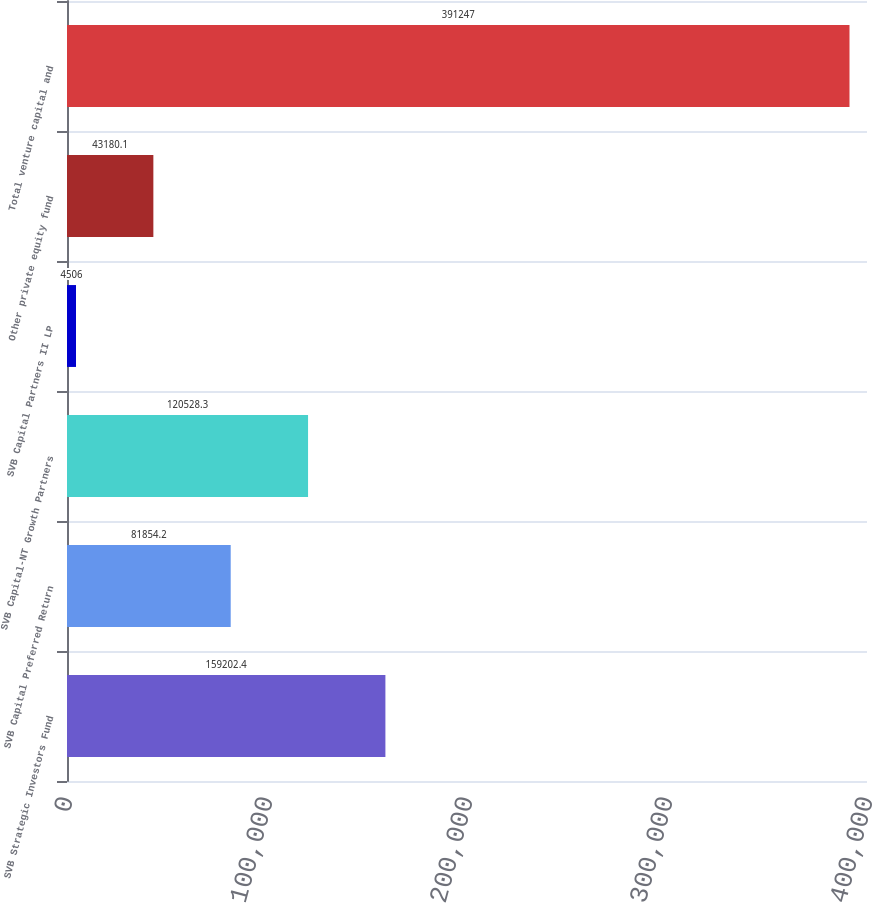<chart> <loc_0><loc_0><loc_500><loc_500><bar_chart><fcel>SVB Strategic Investors Fund<fcel>SVB Capital Preferred Return<fcel>SVB Capital-NT Growth Partners<fcel>SVB Capital Partners II LP<fcel>Other private equity fund<fcel>Total venture capital and<nl><fcel>159202<fcel>81854.2<fcel>120528<fcel>4506<fcel>43180.1<fcel>391247<nl></chart> 